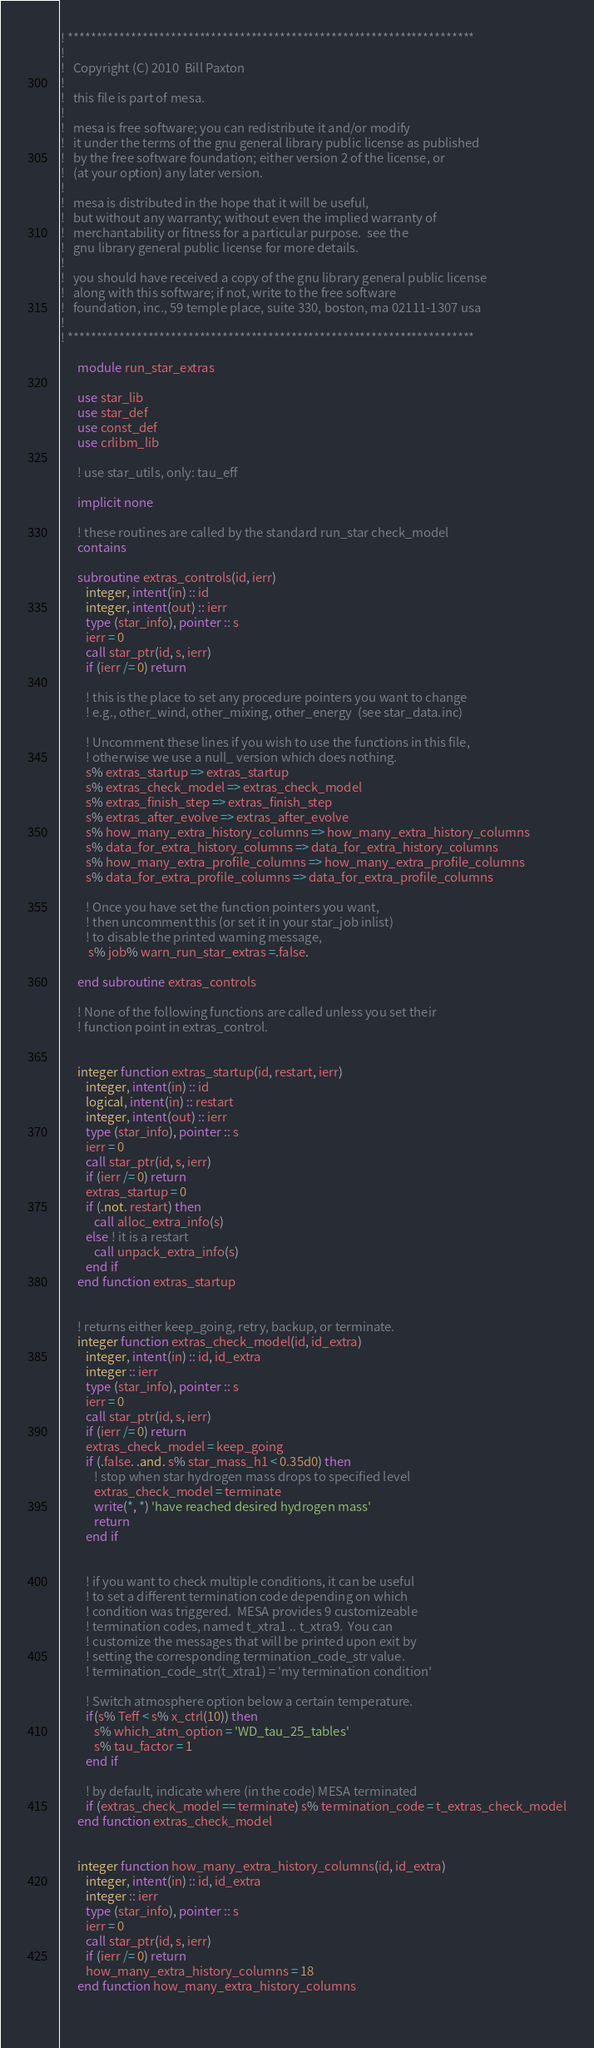Convert code to text. <code><loc_0><loc_0><loc_500><loc_500><_FORTRAN_>! ***********************************************************************
!
!   Copyright (C) 2010  Bill Paxton
!
!   this file is part of mesa.
!
!   mesa is free software; you can redistribute it and/or modify
!   it under the terms of the gnu general library public license as published
!   by the free software foundation; either version 2 of the license, or
!   (at your option) any later version.
!
!   mesa is distributed in the hope that it will be useful, 
!   but without any warranty; without even the implied warranty of
!   merchantability or fitness for a particular purpose.  see the
!   gnu library general public license for more details.
!
!   you should have received a copy of the gnu library general public license
!   along with this software; if not, write to the free software
!   foundation, inc., 59 temple place, suite 330, boston, ma 02111-1307 usa
!
! ***********************************************************************
 
      module run_star_extras

      use star_lib
      use star_def
      use const_def
      use crlibm_lib

      ! use star_utils, only: tau_eff
      
      implicit none
      
      ! these routines are called by the standard run_star check_model
      contains

      subroutine extras_controls(id, ierr)
         integer, intent(in) :: id
         integer, intent(out) :: ierr
         type (star_info), pointer :: s
         ierr = 0
         call star_ptr(id, s, ierr)
         if (ierr /= 0) return
         
         ! this is the place to set any procedure pointers you want to change
         ! e.g., other_wind, other_mixing, other_energy  (see star_data.inc)
         
         ! Uncomment these lines if you wish to use the functions in this file,
         ! otherwise we use a null_ version which does nothing.
         s% extras_startup => extras_startup
         s% extras_check_model => extras_check_model
         s% extras_finish_step => extras_finish_step
         s% extras_after_evolve => extras_after_evolve
         s% how_many_extra_history_columns => how_many_extra_history_columns
         s% data_for_extra_history_columns => data_for_extra_history_columns
         s% how_many_extra_profile_columns => how_many_extra_profile_columns
         s% data_for_extra_profile_columns => data_for_extra_profile_columns  

         ! Once you have set the function pointers you want,
         ! then uncomment this (or set it in your star_job inlist)
         ! to disable the printed warning message,
          s% job% warn_run_star_extras =.false.       
            
      end subroutine extras_controls
      
      ! None of the following functions are called unless you set their
      ! function point in extras_control.
      
      
      integer function extras_startup(id, restart, ierr)
         integer, intent(in) :: id
         logical, intent(in) :: restart
         integer, intent(out) :: ierr
         type (star_info), pointer :: s
         ierr = 0
         call star_ptr(id, s, ierr)
         if (ierr /= 0) return
         extras_startup = 0
         if (.not. restart) then
            call alloc_extra_info(s)
         else ! it is a restart
            call unpack_extra_info(s)
         end if
      end function extras_startup
      

      ! returns either keep_going, retry, backup, or terminate.
      integer function extras_check_model(id, id_extra)
         integer, intent(in) :: id, id_extra
         integer :: ierr
         type (star_info), pointer :: s
         ierr = 0
         call star_ptr(id, s, ierr)
         if (ierr /= 0) return
         extras_check_model = keep_going         
         if (.false. .and. s% star_mass_h1 < 0.35d0) then
            ! stop when star hydrogen mass drops to specified level
            extras_check_model = terminate
            write(*, *) 'have reached desired hydrogen mass'
            return
         end if


         ! if you want to check multiple conditions, it can be useful
         ! to set a different termination code depending on which
         ! condition was triggered.  MESA provides 9 customizeable
         ! termination codes, named t_xtra1 .. t_xtra9.  You can
         ! customize the messages that will be printed upon exit by
         ! setting the corresponding termination_code_str value.
         ! termination_code_str(t_xtra1) = 'my termination condition'

         ! Switch atmosphere option below a certain temperature.
         if(s% Teff < s% x_ctrl(10)) then
            s% which_atm_option = 'WD_tau_25_tables'
            s% tau_factor = 1
         end if

         ! by default, indicate where (in the code) MESA terminated
         if (extras_check_model == terminate) s% termination_code = t_extras_check_model
      end function extras_check_model


      integer function how_many_extra_history_columns(id, id_extra)
         integer, intent(in) :: id, id_extra
         integer :: ierr
         type (star_info), pointer :: s
         ierr = 0
         call star_ptr(id, s, ierr)
         if (ierr /= 0) return
         how_many_extra_history_columns = 18
      end function how_many_extra_history_columns
      
      </code> 